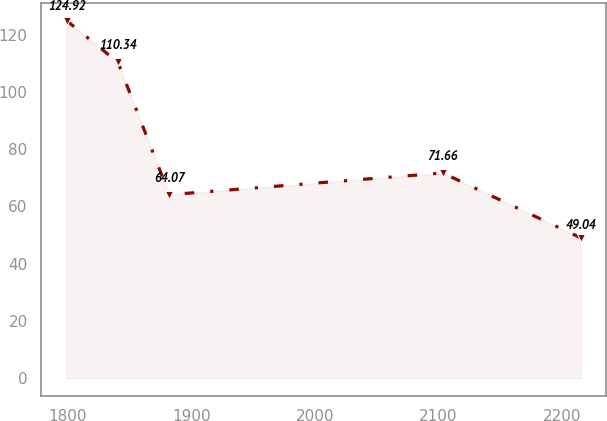<chart> <loc_0><loc_0><loc_500><loc_500><line_chart><ecel><fcel>Unnamed: 1<nl><fcel>1799.11<fcel>124.92<nl><fcel>1840.71<fcel>110.34<nl><fcel>1882.31<fcel>64.07<nl><fcel>2103.64<fcel>71.66<nl><fcel>2215.12<fcel>49.04<nl></chart> 